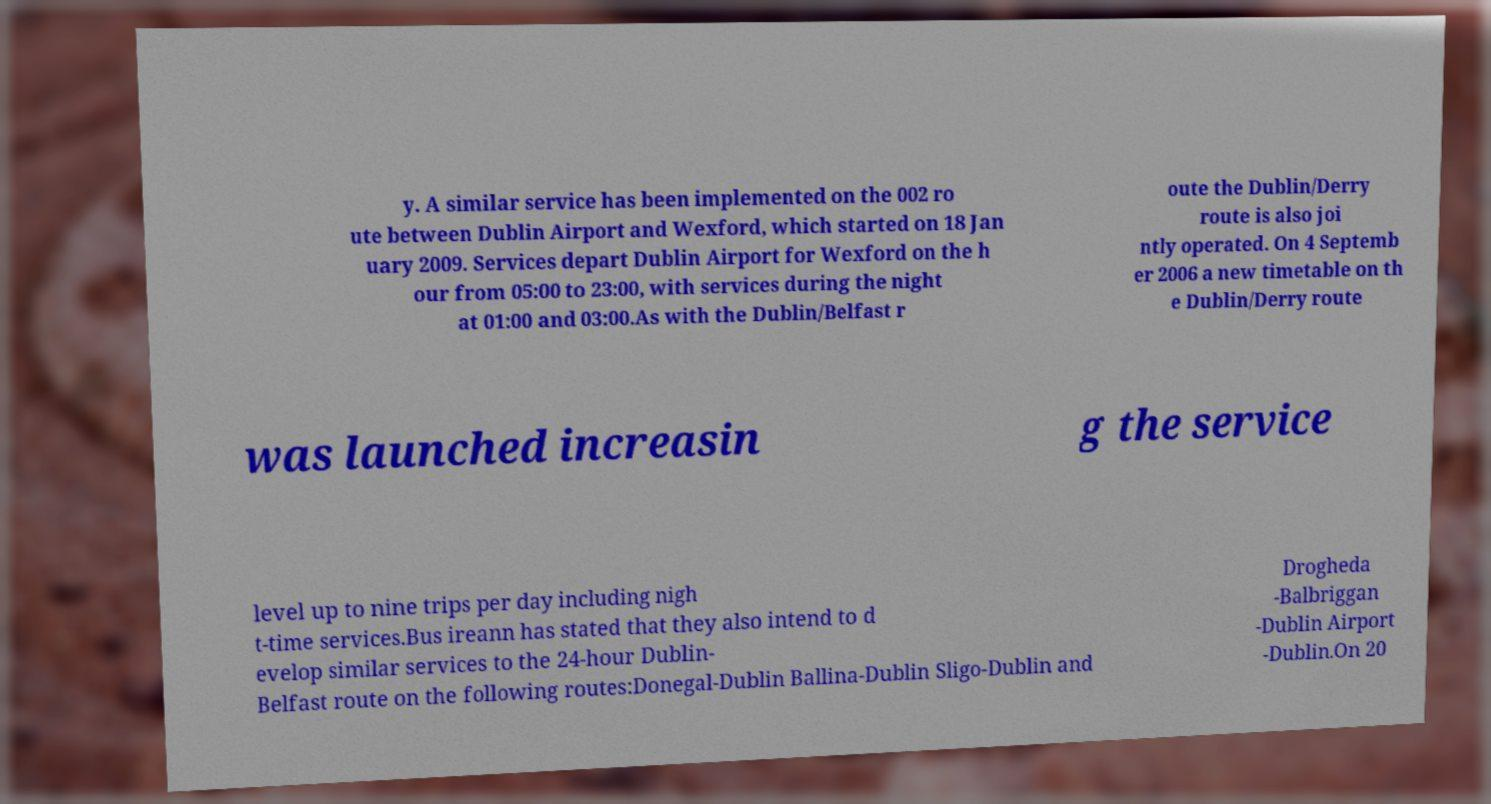Could you extract and type out the text from this image? y. A similar service has been implemented on the 002 ro ute between Dublin Airport and Wexford, which started on 18 Jan uary 2009. Services depart Dublin Airport for Wexford on the h our from 05:00 to 23:00, with services during the night at 01:00 and 03:00.As with the Dublin/Belfast r oute the Dublin/Derry route is also joi ntly operated. On 4 Septemb er 2006 a new timetable on th e Dublin/Derry route was launched increasin g the service level up to nine trips per day including nigh t-time services.Bus ireann has stated that they also intend to d evelop similar services to the 24-hour Dublin- Belfast route on the following routes:Donegal-Dublin Ballina-Dublin Sligo-Dublin and Drogheda -Balbriggan -Dublin Airport -Dublin.On 20 